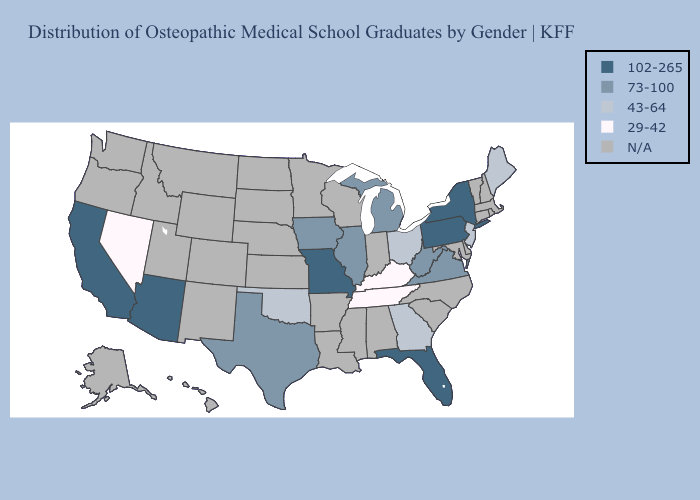What is the value of Michigan?
Keep it brief. 73-100. Among the states that border Missouri , which have the highest value?
Write a very short answer. Illinois, Iowa. Does the first symbol in the legend represent the smallest category?
Short answer required. No. Among the states that border Kansas , which have the lowest value?
Be succinct. Oklahoma. Which states have the lowest value in the USA?
Quick response, please. Kentucky, Nevada, Tennessee. Does the map have missing data?
Short answer required. Yes. What is the value of Wisconsin?
Concise answer only. N/A. What is the lowest value in states that border Oklahoma?
Quick response, please. 73-100. Among the states that border Ohio , does Kentucky have the highest value?
Answer briefly. No. What is the highest value in the West ?
Answer briefly. 102-265. Does the map have missing data?
Be succinct. Yes. What is the lowest value in the MidWest?
Answer briefly. 43-64. What is the value of Kansas?
Concise answer only. N/A. Is the legend a continuous bar?
Be succinct. No. 